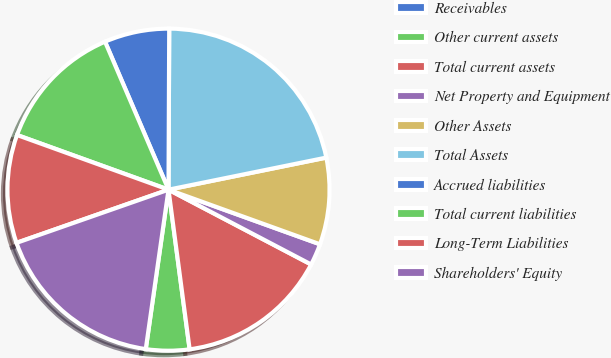<chart> <loc_0><loc_0><loc_500><loc_500><pie_chart><fcel>Receivables<fcel>Other current assets<fcel>Total current assets<fcel>Net Property and Equipment<fcel>Other Assets<fcel>Total Assets<fcel>Accrued liabilities<fcel>Total current liabilities<fcel>Long-Term Liabilities<fcel>Shareholders' Equity<nl><fcel>0.0%<fcel>4.35%<fcel>15.22%<fcel>2.18%<fcel>8.7%<fcel>21.74%<fcel>6.52%<fcel>13.04%<fcel>10.87%<fcel>17.39%<nl></chart> 